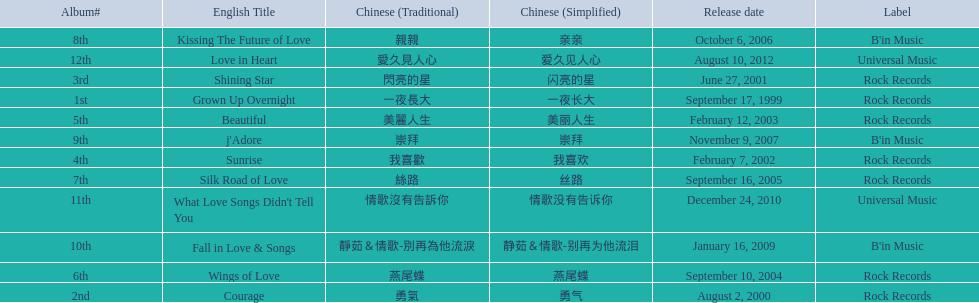What were the albums? Grown Up Overnight, Courage, Shining Star, Sunrise, Beautiful, Wings of Love, Silk Road of Love, Kissing The Future of Love, j'Adore, Fall in Love & Songs, What Love Songs Didn't Tell You, Love in Heart. Which ones were released by b'in music? Kissing The Future of Love, j'Adore. Of these, which one was in an even-numbered year? Kissing The Future of Love. 